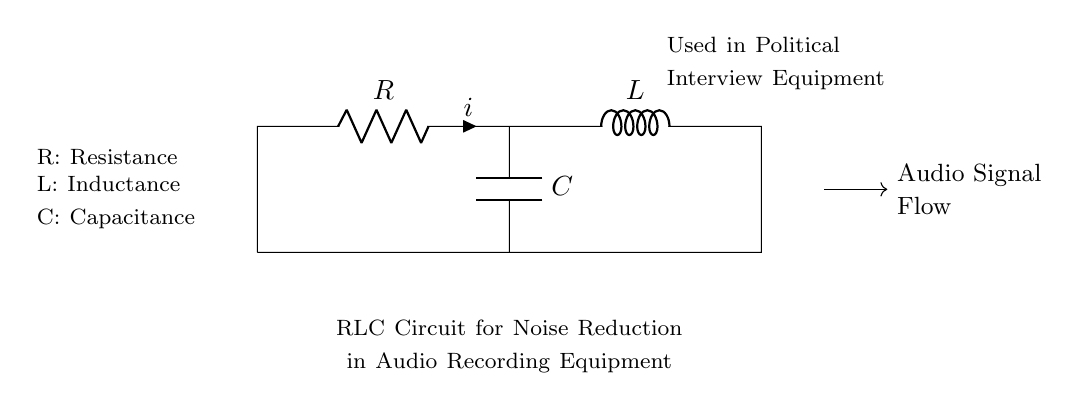What are the components in the circuit? The circuit contains three components: a resistor, an inductor, and a capacitor. These components are labeled in the diagram and are essential for the noise reduction function.
Answer: resistor, inductor, capacitor What type of circuit is represented? This is an RLC circuit, which incorporates a resistor, an inductor, and a capacitor connected to reduce noise in audio signals. The label in the diagram confirms its purpose in audio recording equipment.
Answer: RLC circuit What is the purpose of the RLC circuit in political interviews? The purpose is to reduce noise in audio recording equipment used during interviews, ensuring clear sound quality for political reporting. The specific labeling in the diagram highlights this application.
Answer: noise reduction What does the 'i' represent in the diagram? The 'i' in the diagram represents the current flowing through the resistor. It is commonly used as a notation in circuit diagrams to indicate the current direction and magnitude.
Answer: current How does the combination of R, L, and C affect sound quality? The combination filters frequencies, attenuating unwanted noise while preserving desirable audio signals, thus improving sound quality. This effect is due to the reactive properties of the inductor and capacitor in relation to resistance.
Answer: filters frequencies What is the role of capacitance in this circuit? The role of capacitance is to store and release electrical energy, which helps smooth out voltage variations, improving signal quality in audio recordings. The capacitor's placement impacts how it interacts with the other components.
Answer: store energy 